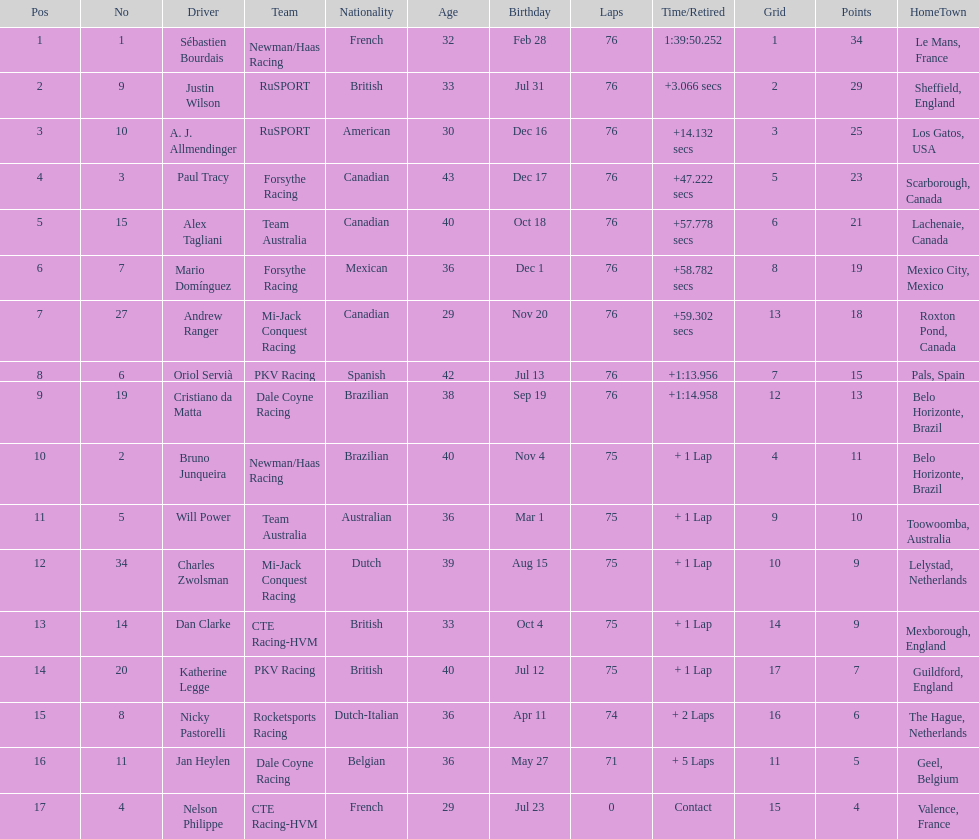How many drivers were competing for brazil? 2. 